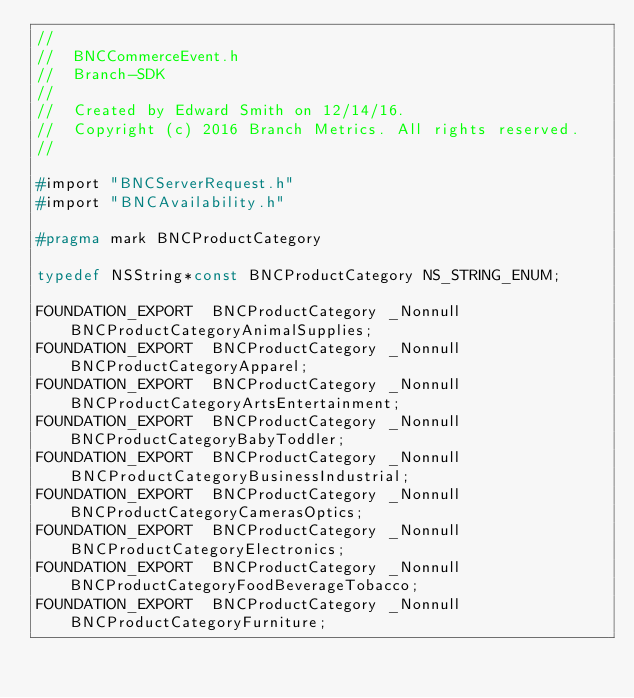<code> <loc_0><loc_0><loc_500><loc_500><_C_>//
//  BNCCommerceEvent.h
//  Branch-SDK
//
//  Created by Edward Smith on 12/14/16.
//  Copyright (c) 2016 Branch Metrics. All rights reserved.
//

#import "BNCServerRequest.h"
#import "BNCAvailability.h"

#pragma mark BNCProductCategory

typedef NSString*const BNCProductCategory NS_STRING_ENUM;

FOUNDATION_EXPORT  BNCProductCategory _Nonnull BNCProductCategoryAnimalSupplies;
FOUNDATION_EXPORT  BNCProductCategory _Nonnull BNCProductCategoryApparel;
FOUNDATION_EXPORT  BNCProductCategory _Nonnull BNCProductCategoryArtsEntertainment;
FOUNDATION_EXPORT  BNCProductCategory _Nonnull BNCProductCategoryBabyToddler;
FOUNDATION_EXPORT  BNCProductCategory _Nonnull BNCProductCategoryBusinessIndustrial;
FOUNDATION_EXPORT  BNCProductCategory _Nonnull BNCProductCategoryCamerasOptics;
FOUNDATION_EXPORT  BNCProductCategory _Nonnull BNCProductCategoryElectronics;
FOUNDATION_EXPORT  BNCProductCategory _Nonnull BNCProductCategoryFoodBeverageTobacco;
FOUNDATION_EXPORT  BNCProductCategory _Nonnull BNCProductCategoryFurniture;</code> 